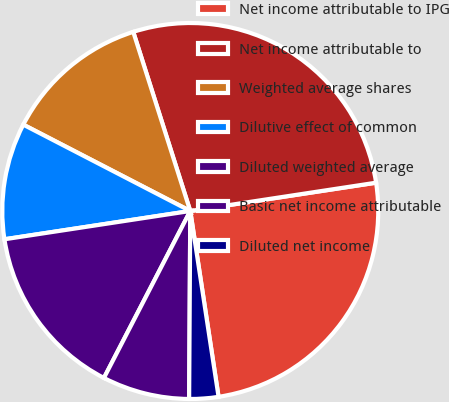Convert chart to OTSL. <chart><loc_0><loc_0><loc_500><loc_500><pie_chart><fcel>Net income attributable to IPG<fcel>Net income attributable to<fcel>Weighted average shares<fcel>Dilutive effect of common<fcel>Diluted weighted average<fcel>Basic net income attributable<fcel>Diluted net income<nl><fcel>25.0%<fcel>27.5%<fcel>12.5%<fcel>10.0%<fcel>15.0%<fcel>7.5%<fcel>2.5%<nl></chart> 